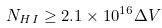Convert formula to latex. <formula><loc_0><loc_0><loc_500><loc_500>N _ { H I } \geq 2 . 1 \times 1 0 ^ { 1 6 } \Delta V</formula> 